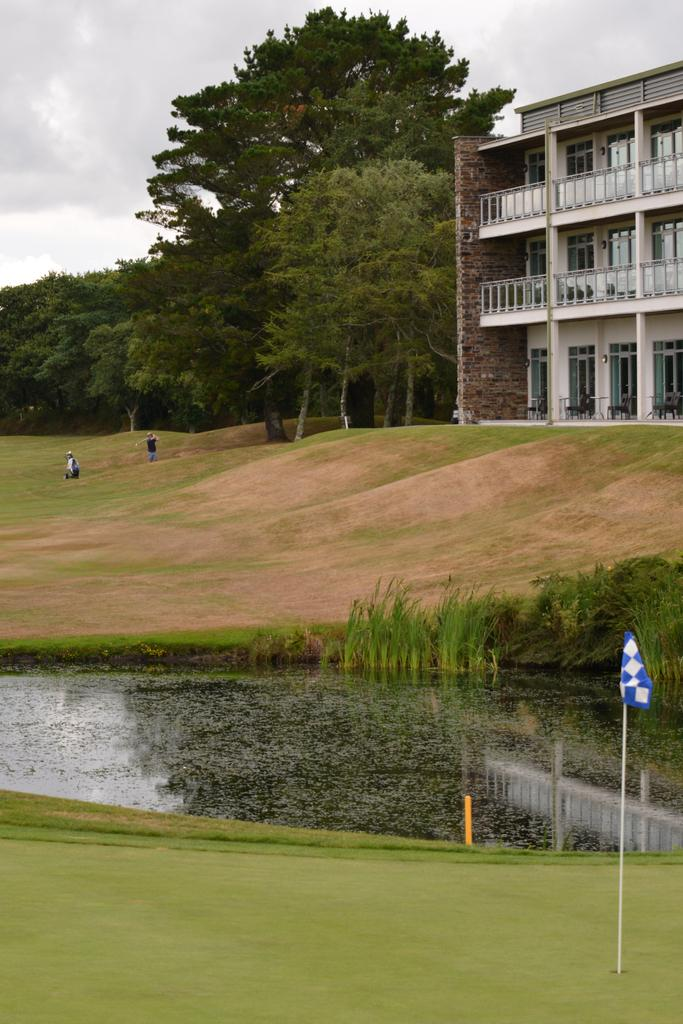What type of flag is present in the image? There is a blue and white color flag in the image. What can be seen in the background of the image? There is a building and trees visible in the image. How many people are in the image? There are two persons in the image. What else is visible in the image besides the flag and people? There is water visible in the image. What is the color of the sky in the image? The sky appears to be white in color. What type of pollution can be seen in the image? There is no indication of pollution in the image. What is the reason for the white sky in the image? The color of the sky is a natural occurrence and not due to any specific reason. Can you see a basket in the image? There is no basket present in the image. 